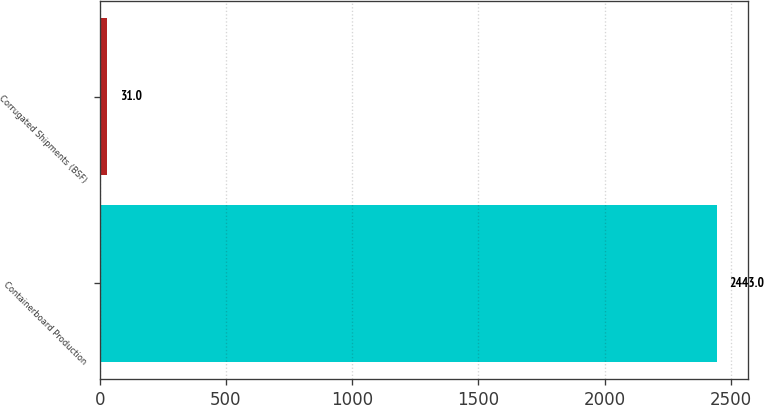Convert chart. <chart><loc_0><loc_0><loc_500><loc_500><bar_chart><fcel>Containerboard Production<fcel>Corrugated Shipments (BSF)<nl><fcel>2443<fcel>31<nl></chart> 